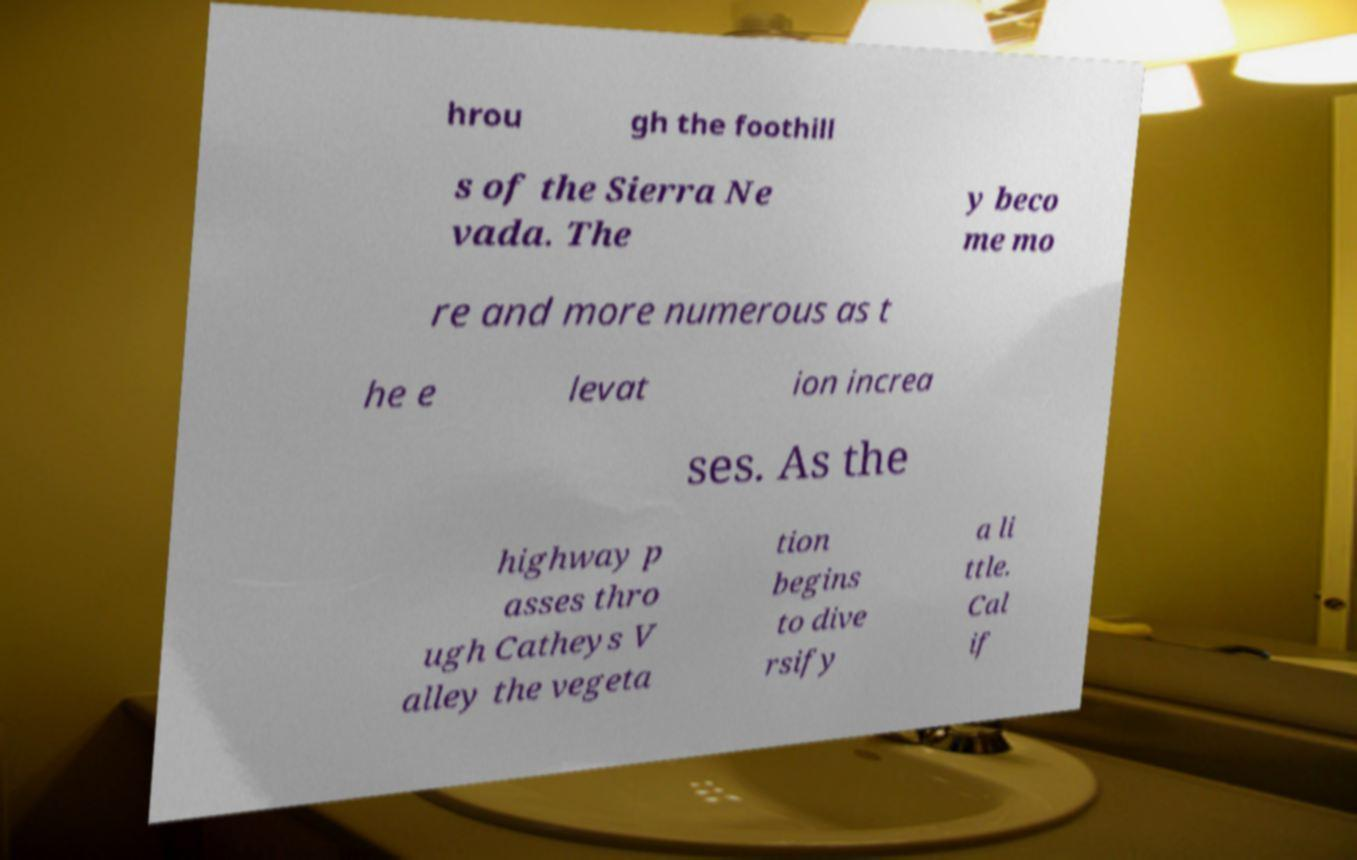Can you read and provide the text displayed in the image?This photo seems to have some interesting text. Can you extract and type it out for me? hrou gh the foothill s of the Sierra Ne vada. The y beco me mo re and more numerous as t he e levat ion increa ses. As the highway p asses thro ugh Catheys V alley the vegeta tion begins to dive rsify a li ttle. Cal if 